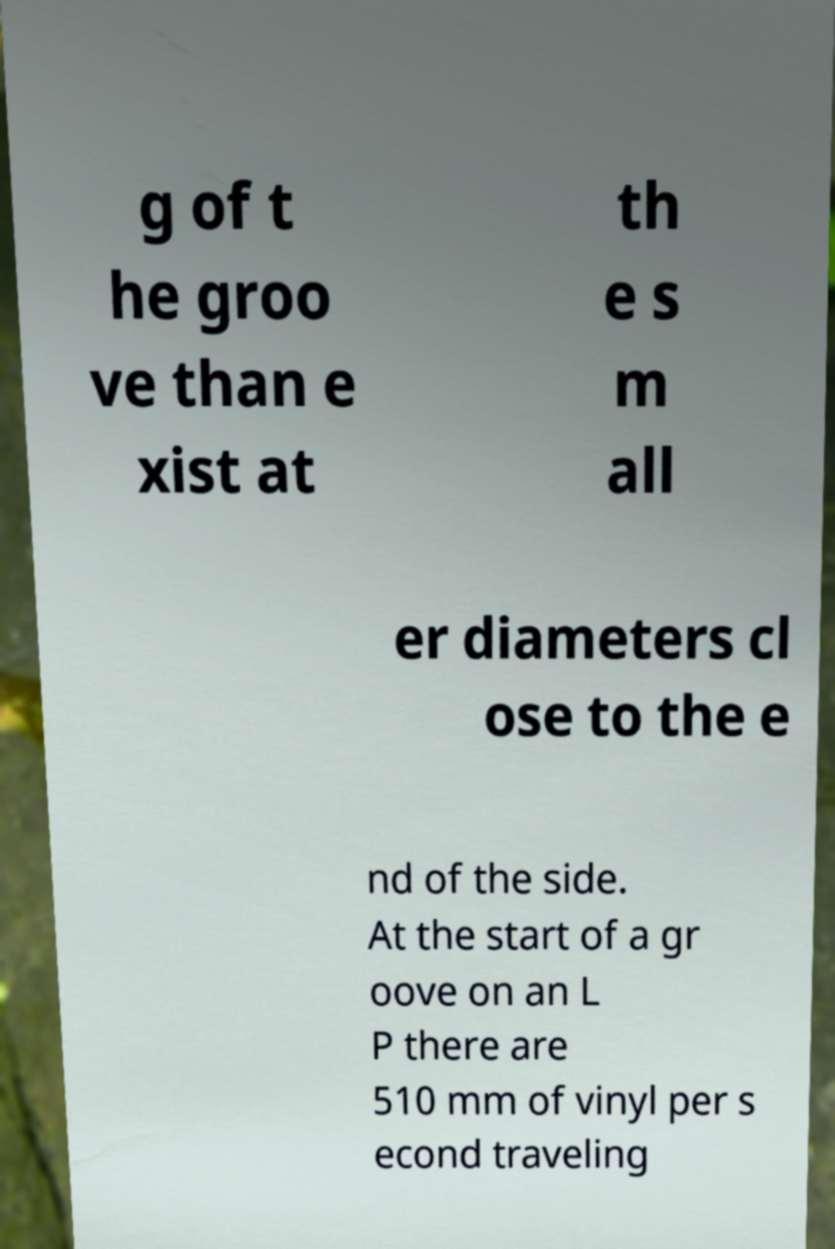Could you assist in decoding the text presented in this image and type it out clearly? g of t he groo ve than e xist at th e s m all er diameters cl ose to the e nd of the side. At the start of a gr oove on an L P there are 510 mm of vinyl per s econd traveling 